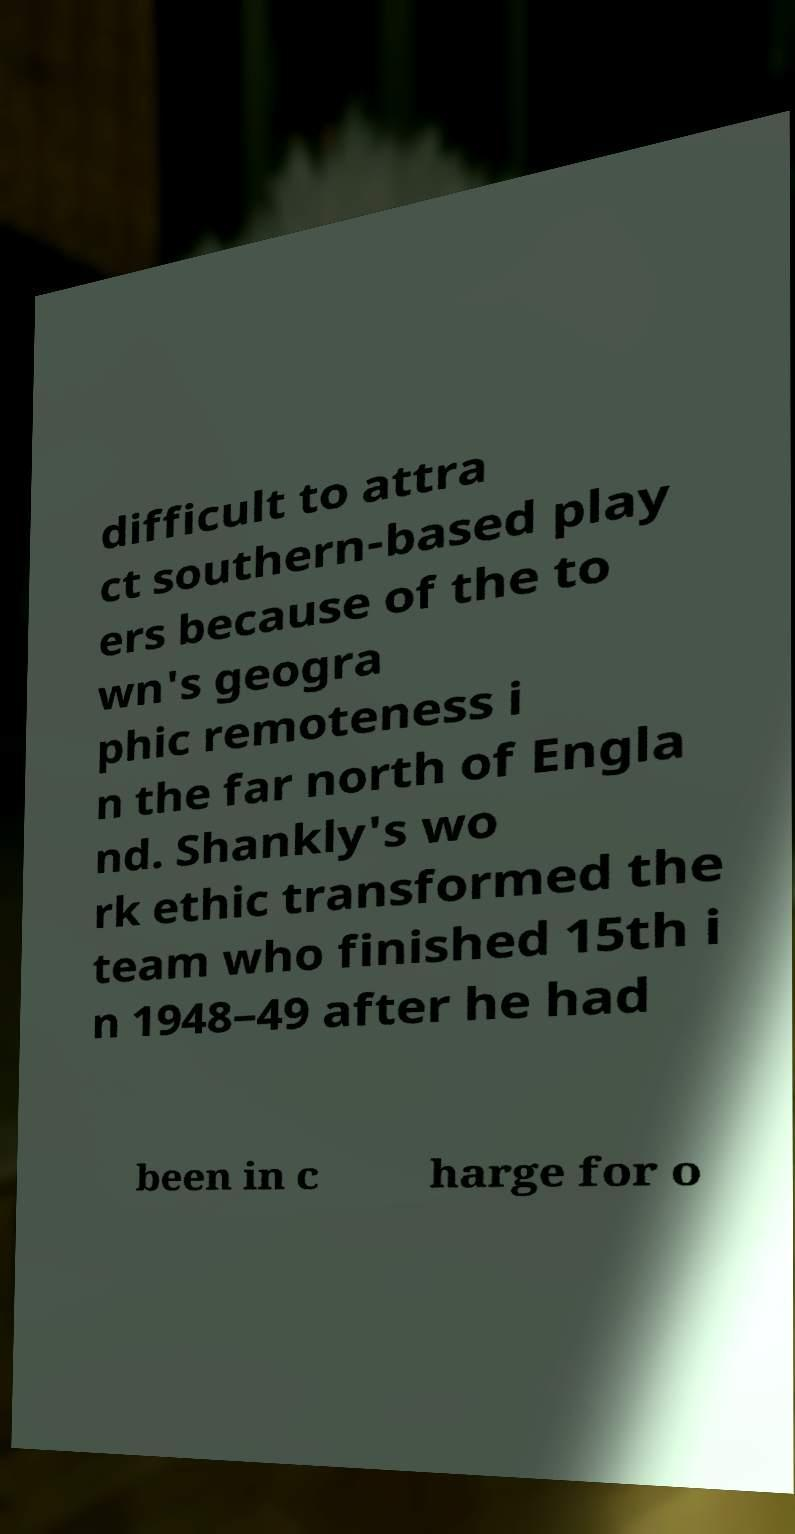Please read and relay the text visible in this image. What does it say? difficult to attra ct southern-based play ers because of the to wn's geogra phic remoteness i n the far north of Engla nd. Shankly's wo rk ethic transformed the team who finished 15th i n 1948–49 after he had been in c harge for o 